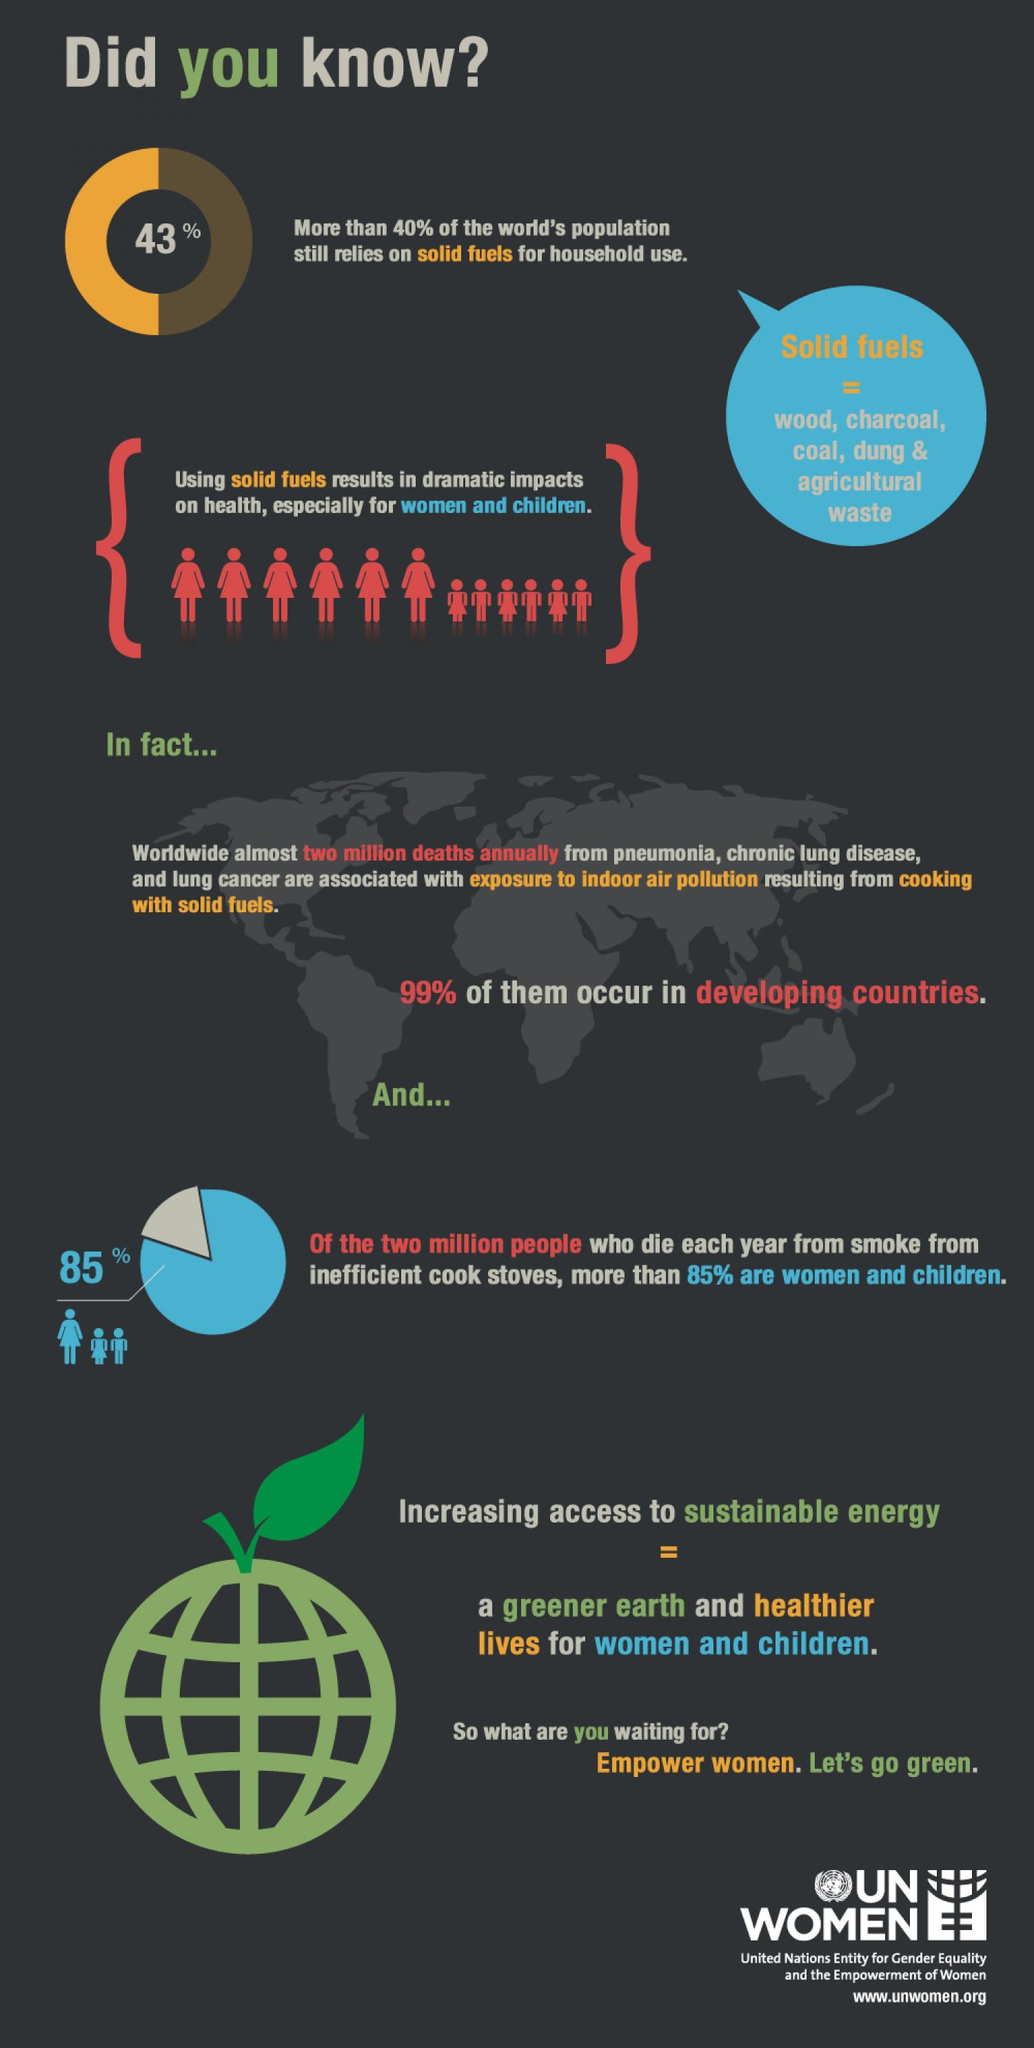Give some essential details in this illustration. Approximately 15% of men are casualties to cooking smoke, indicating the significant harm caused by exposure to harmful smoke particles. 